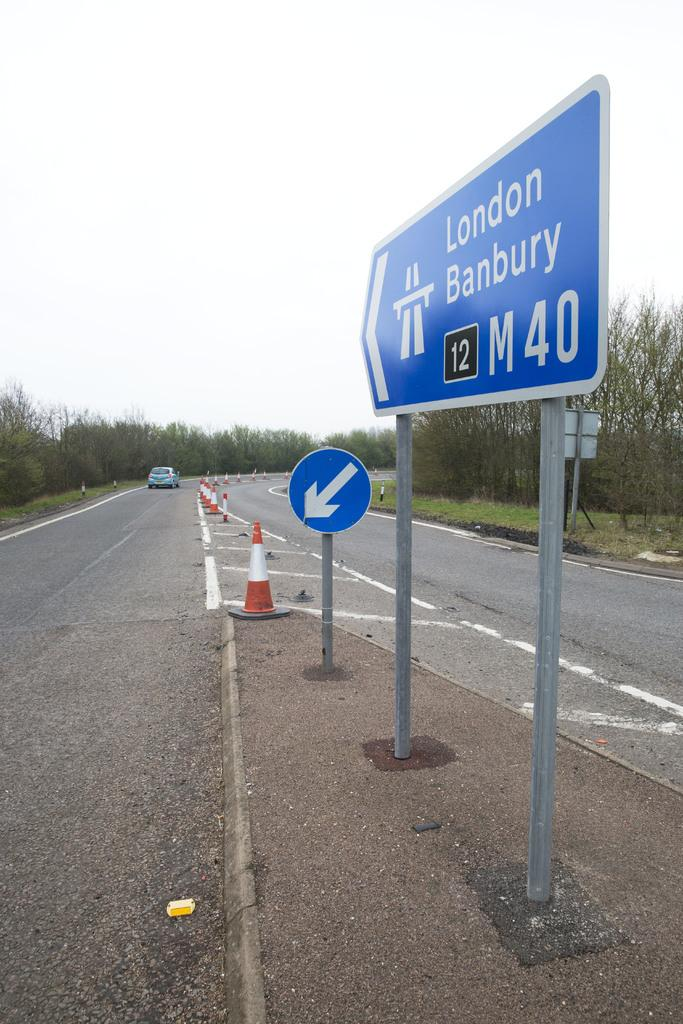Provide a one-sentence caption for the provided image. A blue sign points to London Banbury and states, "M40". 